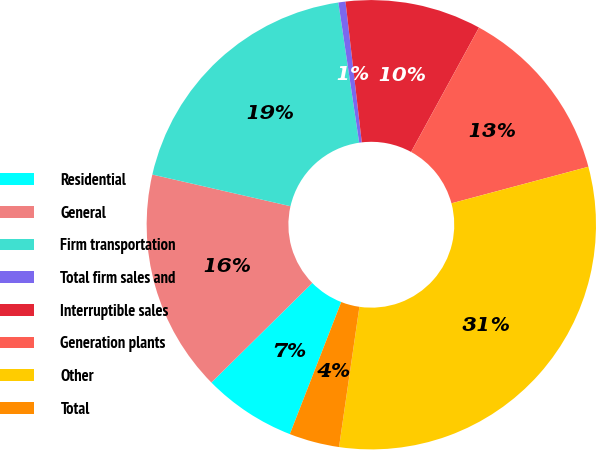<chart> <loc_0><loc_0><loc_500><loc_500><pie_chart><fcel>Residential<fcel>General<fcel>Firm transportation<fcel>Total firm sales and<fcel>Interruptible sales<fcel>Generation plants<fcel>Other<fcel>Total<nl><fcel>6.7%<fcel>15.98%<fcel>19.07%<fcel>0.51%<fcel>9.79%<fcel>12.89%<fcel>31.45%<fcel>3.61%<nl></chart> 